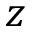Convert formula to latex. <formula><loc_0><loc_0><loc_500><loc_500>z</formula> 